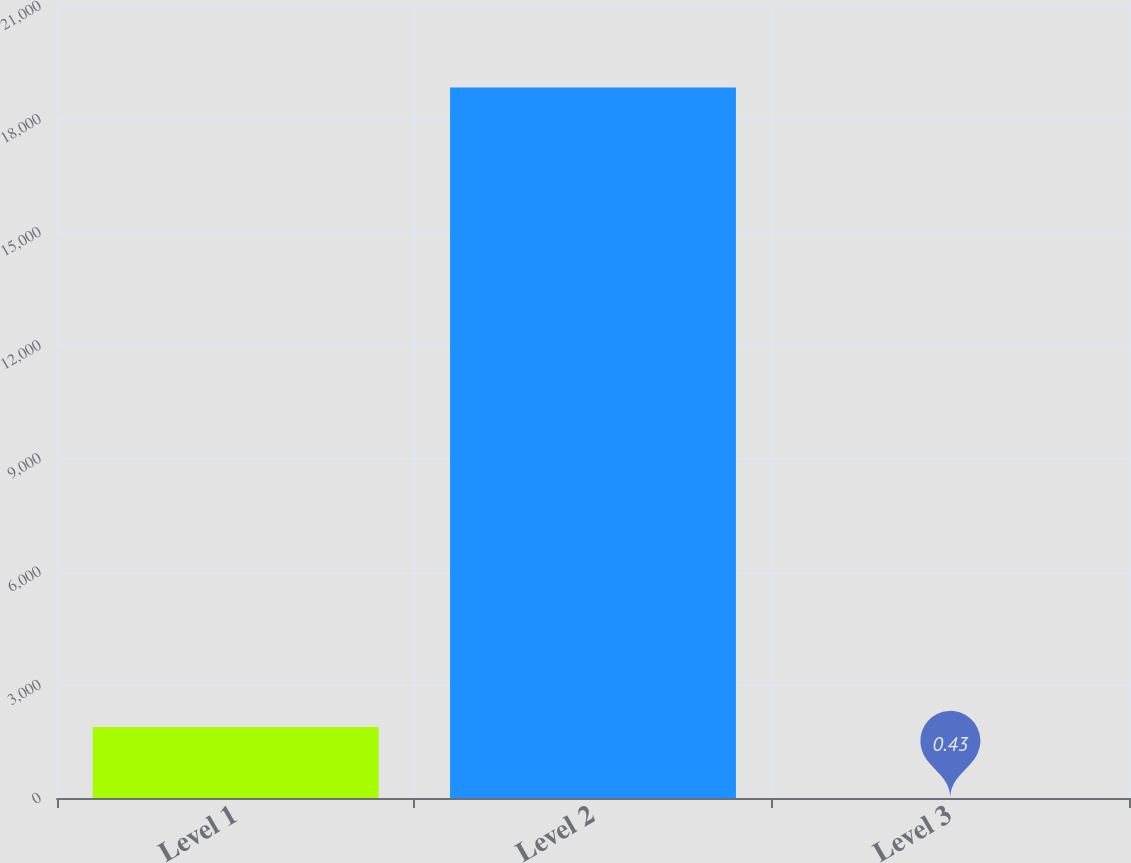<chart> <loc_0><loc_0><loc_500><loc_500><bar_chart><fcel>Level 1<fcel>Level 2<fcel>Level 3<nl><fcel>1883.99<fcel>18836<fcel>0.43<nl></chart> 